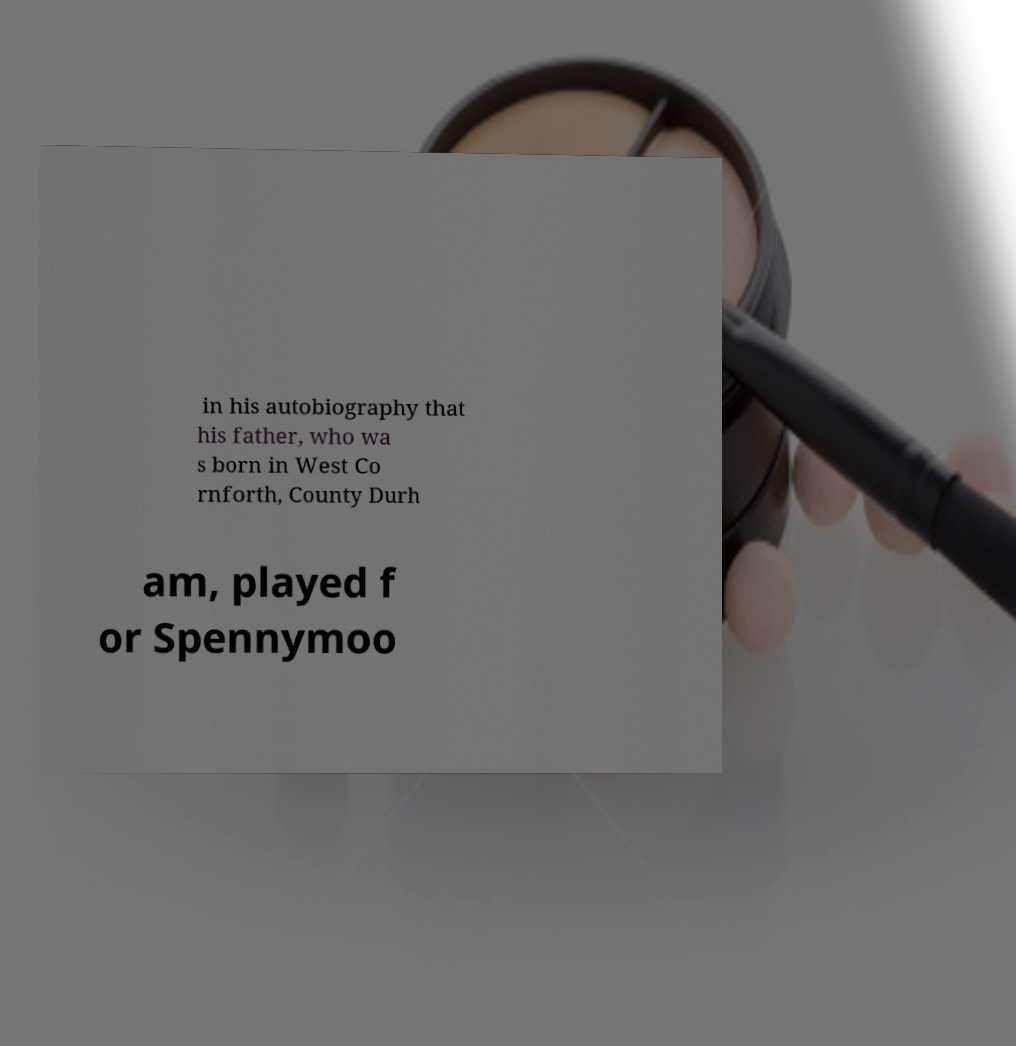Could you assist in decoding the text presented in this image and type it out clearly? in his autobiography that his father, who wa s born in West Co rnforth, County Durh am, played f or Spennymoo 